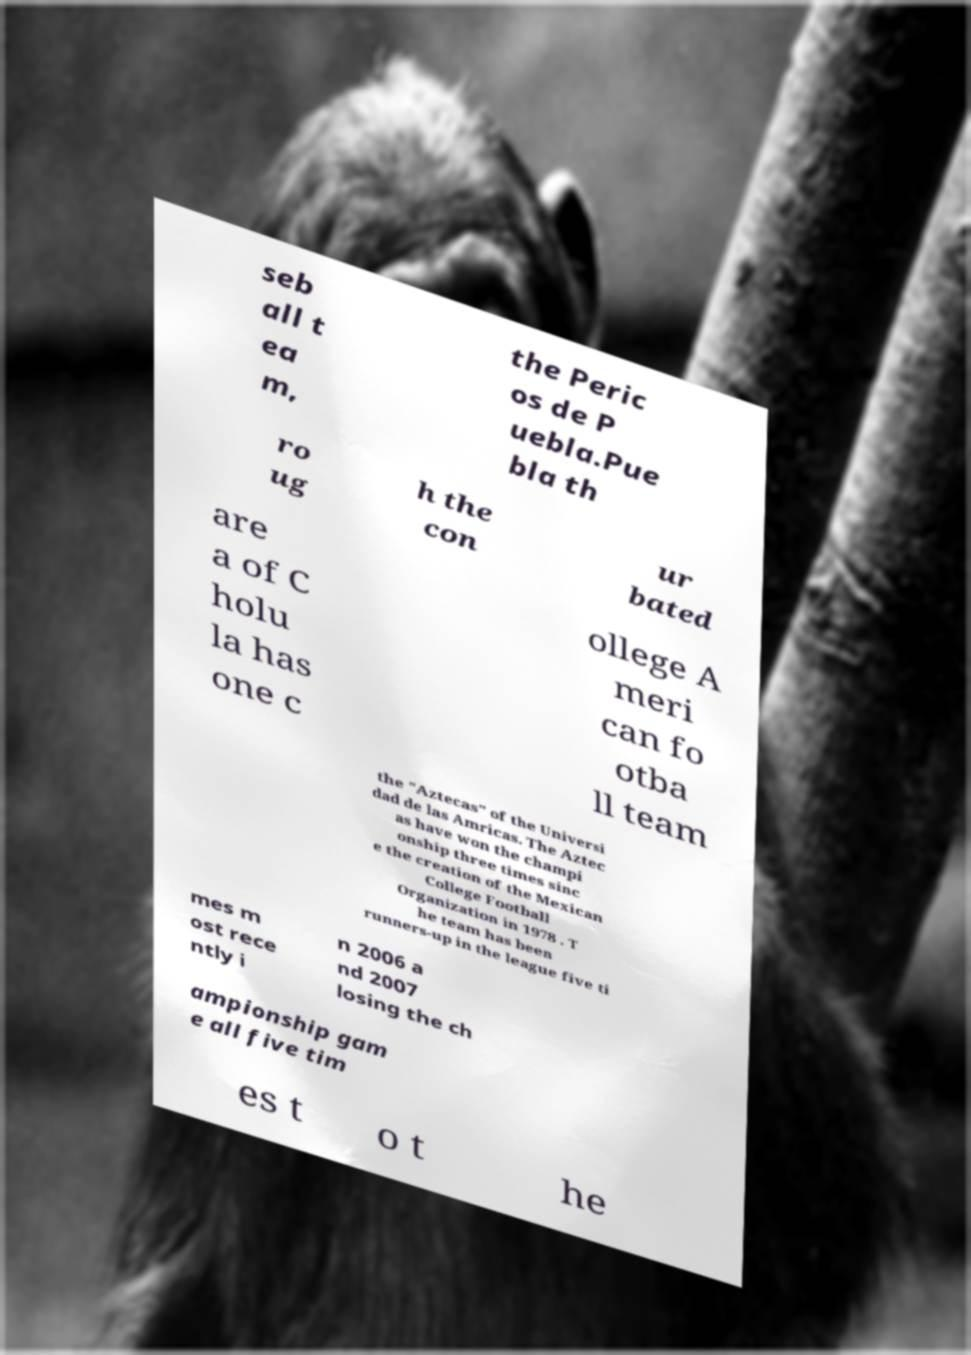Can you accurately transcribe the text from the provided image for me? seb all t ea m, the Peric os de P uebla.Pue bla th ro ug h the con ur bated are a of C holu la has one c ollege A meri can fo otba ll team the "Aztecas" of the Universi dad de las Amricas. The Aztec as have won the champi onship three times sinc e the creation of the Mexican College Football Organization in 1978 . T he team has been runners-up in the league five ti mes m ost rece ntly i n 2006 a nd 2007 losing the ch ampionship gam e all five tim es t o t he 